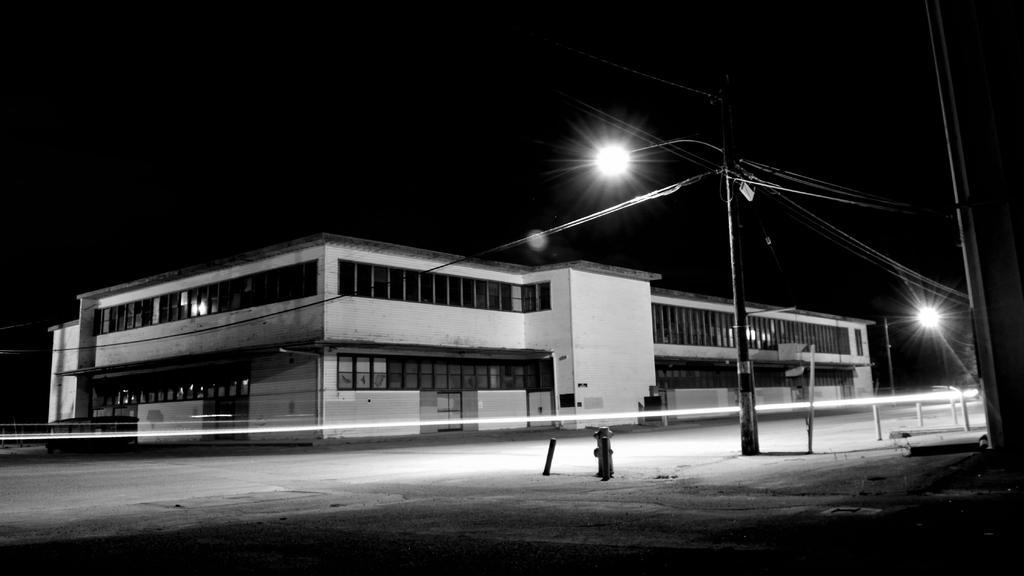What is the color scheme of the image? The image is in black and white. What is the main subject in the center of the image? There is a building in the center of the image. What is located in front of the building? There is a road in front of the building. What can be seen beside the road? There are poles with lights beside the road. How would you describe the background of the image? The background of the image is dark. Where is the nearest hydrant to the building in the image? There is no hydrant visible in the image. What type of authority is depicted in the image? There is no authority figure depicted in the image. 